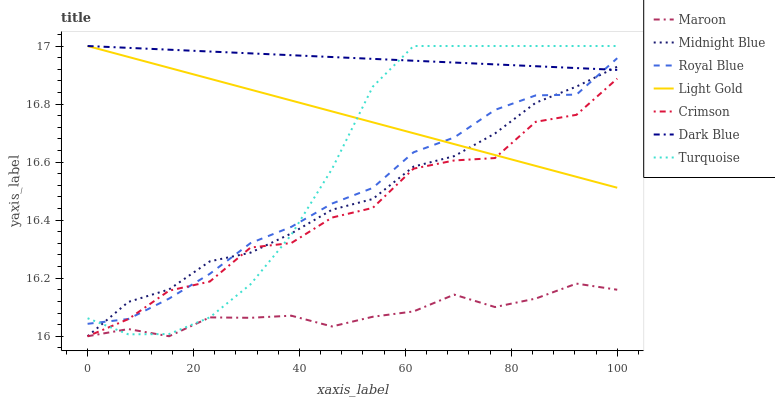Does Maroon have the minimum area under the curve?
Answer yes or no. Yes. Does Dark Blue have the maximum area under the curve?
Answer yes or no. Yes. Does Midnight Blue have the minimum area under the curve?
Answer yes or no. No. Does Midnight Blue have the maximum area under the curve?
Answer yes or no. No. Is Light Gold the smoothest?
Answer yes or no. Yes. Is Crimson the roughest?
Answer yes or no. Yes. Is Midnight Blue the smoothest?
Answer yes or no. No. Is Midnight Blue the roughest?
Answer yes or no. No. Does Midnight Blue have the lowest value?
Answer yes or no. Yes. Does Dark Blue have the lowest value?
Answer yes or no. No. Does Light Gold have the highest value?
Answer yes or no. Yes. Does Midnight Blue have the highest value?
Answer yes or no. No. Is Maroon less than Dark Blue?
Answer yes or no. Yes. Is Royal Blue greater than Maroon?
Answer yes or no. Yes. Does Turquoise intersect Crimson?
Answer yes or no. Yes. Is Turquoise less than Crimson?
Answer yes or no. No. Is Turquoise greater than Crimson?
Answer yes or no. No. Does Maroon intersect Dark Blue?
Answer yes or no. No. 